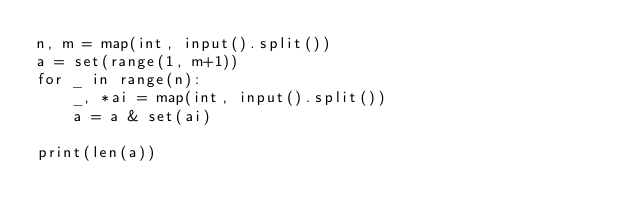<code> <loc_0><loc_0><loc_500><loc_500><_Python_>n, m = map(int, input().split())
a = set(range(1, m+1))
for _ in range(n):
    _, *ai = map(int, input().split())
    a = a & set(ai)

print(len(a))
</code> 